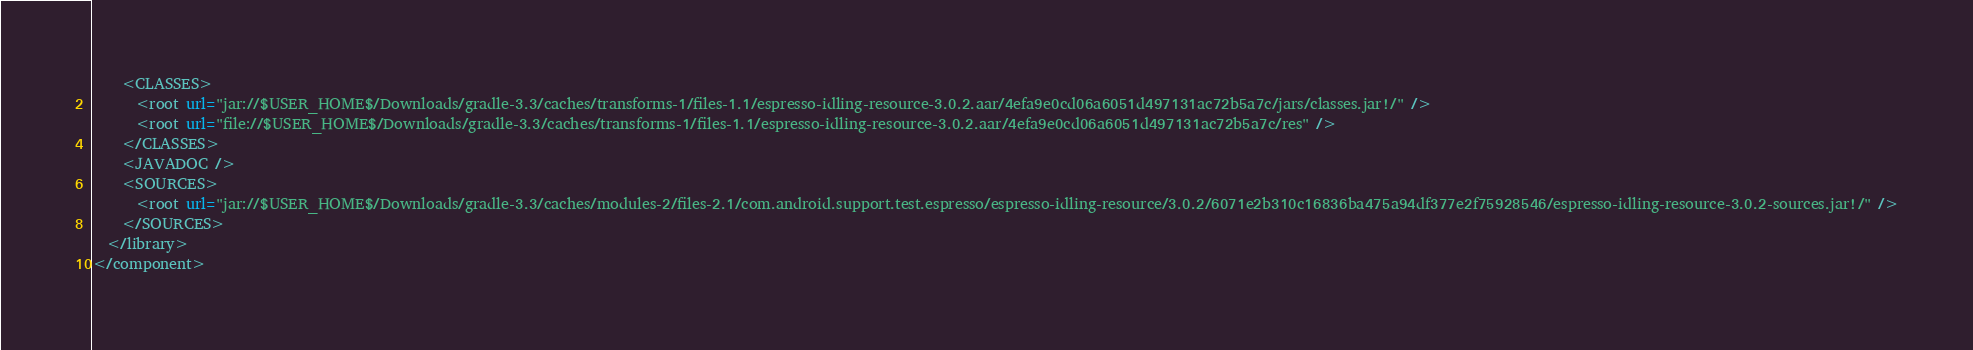<code> <loc_0><loc_0><loc_500><loc_500><_XML_>    <CLASSES>
      <root url="jar://$USER_HOME$/Downloads/gradle-3.3/caches/transforms-1/files-1.1/espresso-idling-resource-3.0.2.aar/4efa9e0cd06a6051d497131ac72b5a7c/jars/classes.jar!/" />
      <root url="file://$USER_HOME$/Downloads/gradle-3.3/caches/transforms-1/files-1.1/espresso-idling-resource-3.0.2.aar/4efa9e0cd06a6051d497131ac72b5a7c/res" />
    </CLASSES>
    <JAVADOC />
    <SOURCES>
      <root url="jar://$USER_HOME$/Downloads/gradle-3.3/caches/modules-2/files-2.1/com.android.support.test.espresso/espresso-idling-resource/3.0.2/6071e2b310c16836ba475a94df377e2f75928546/espresso-idling-resource-3.0.2-sources.jar!/" />
    </SOURCES>
  </library>
</component></code> 